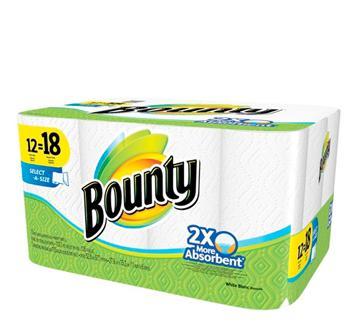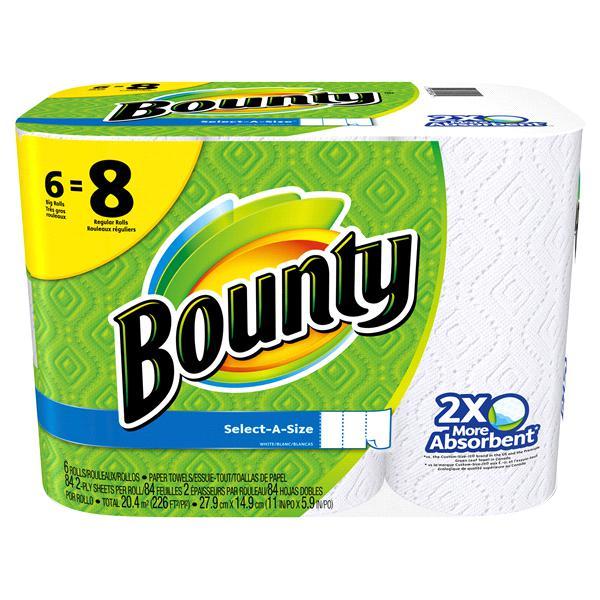The first image is the image on the left, the second image is the image on the right. For the images shown, is this caption "There are 1 or more packages of paper towels facing right." true? Answer yes or no. No. 